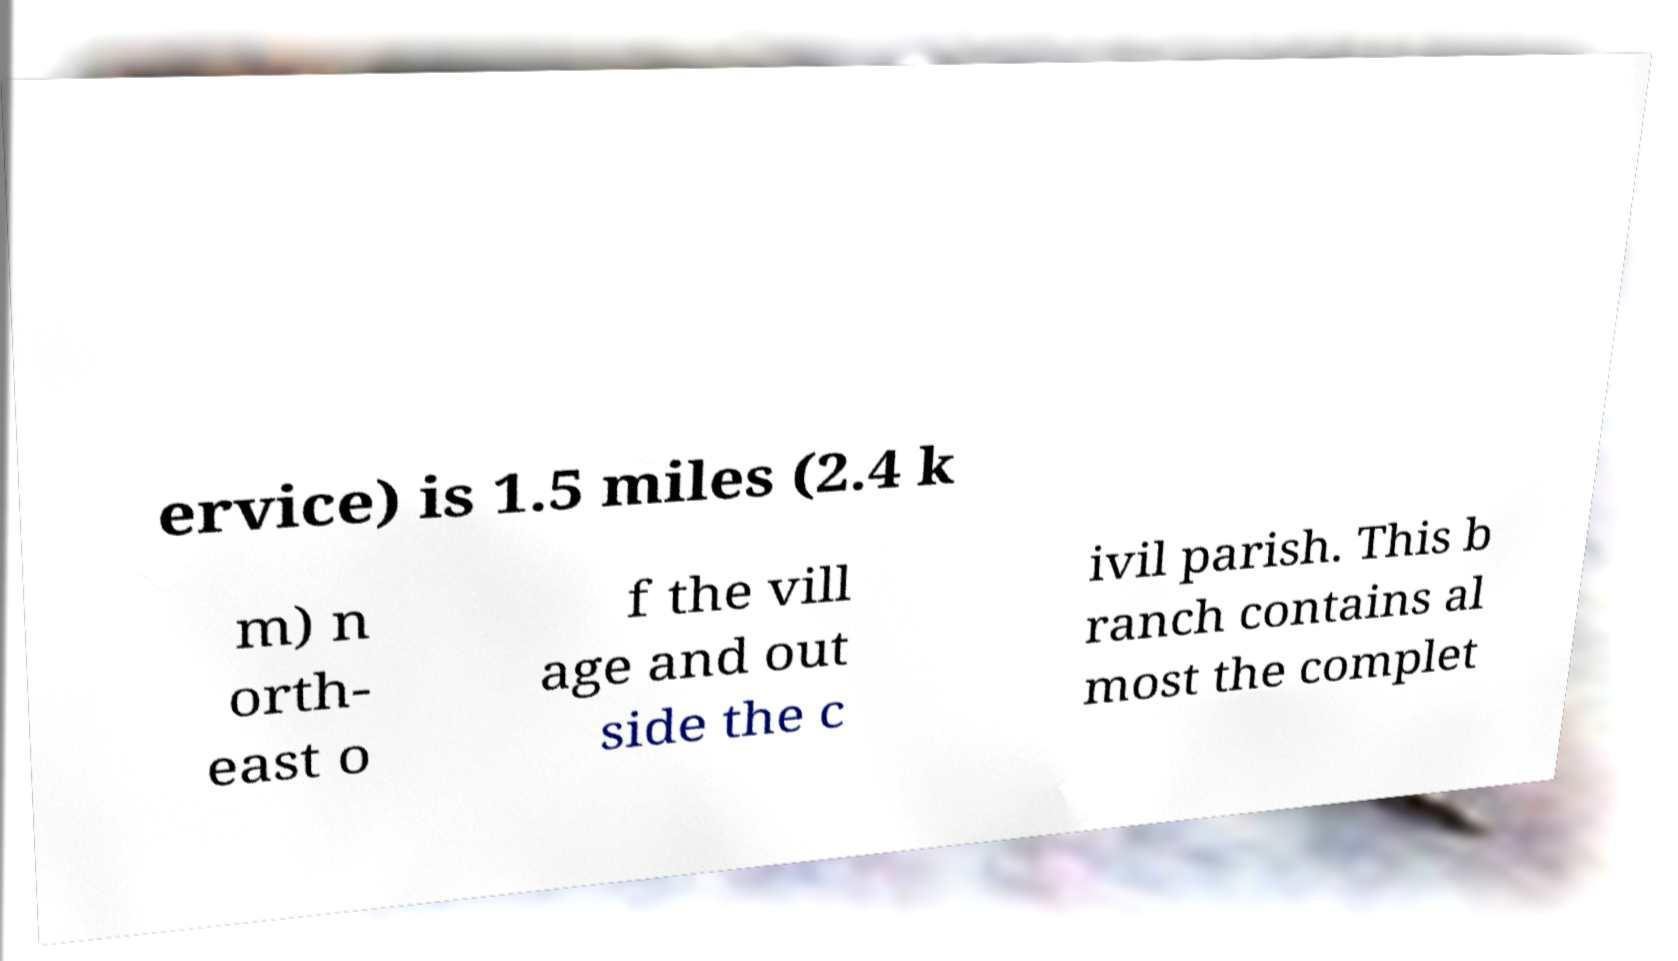Please read and relay the text visible in this image. What does it say? ervice) is 1.5 miles (2.4 k m) n orth- east o f the vill age and out side the c ivil parish. This b ranch contains al most the complet 